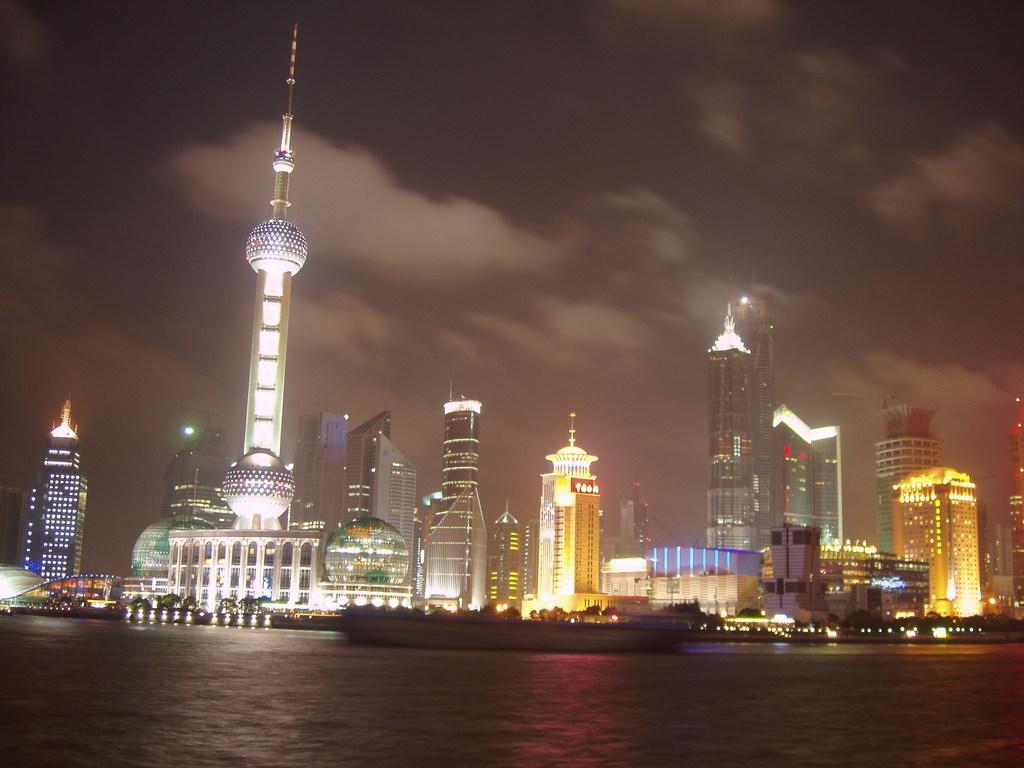Can you describe this image briefly? In the picture we can see water, boats and in the background of the picture there are some buildings and dark sky. 